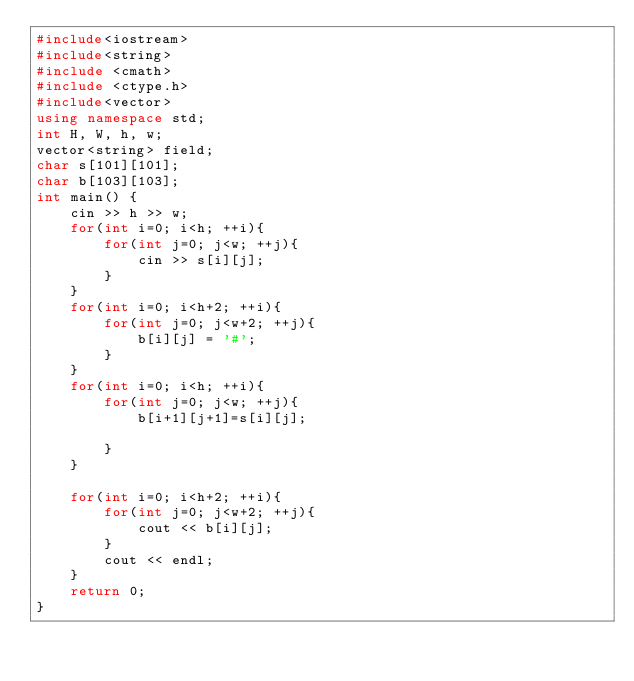<code> <loc_0><loc_0><loc_500><loc_500><_C++_>#include<iostream>
#include<string>
#include <cmath>
#include <ctype.h>
#include<vector>
using namespace std;
int H, W, h, w;
vector<string> field;
char s[101][101];
char b[103][103];
int main() {
    cin >> h >> w;
    for(int i=0; i<h; ++i){
        for(int j=0; j<w; ++j){
            cin >> s[i][j];
        }
    }
    for(int i=0; i<h+2; ++i){
        for(int j=0; j<w+2; ++j){
            b[i][j] = '#';
        }
    }
    for(int i=0; i<h; ++i){
        for(int j=0; j<w; ++j){
            b[i+1][j+1]=s[i][j];
            
        }
    }
    
    for(int i=0; i<h+2; ++i){
        for(int j=0; j<w+2; ++j){
            cout << b[i][j];
        }
        cout << endl;
    }
    return 0;
}</code> 